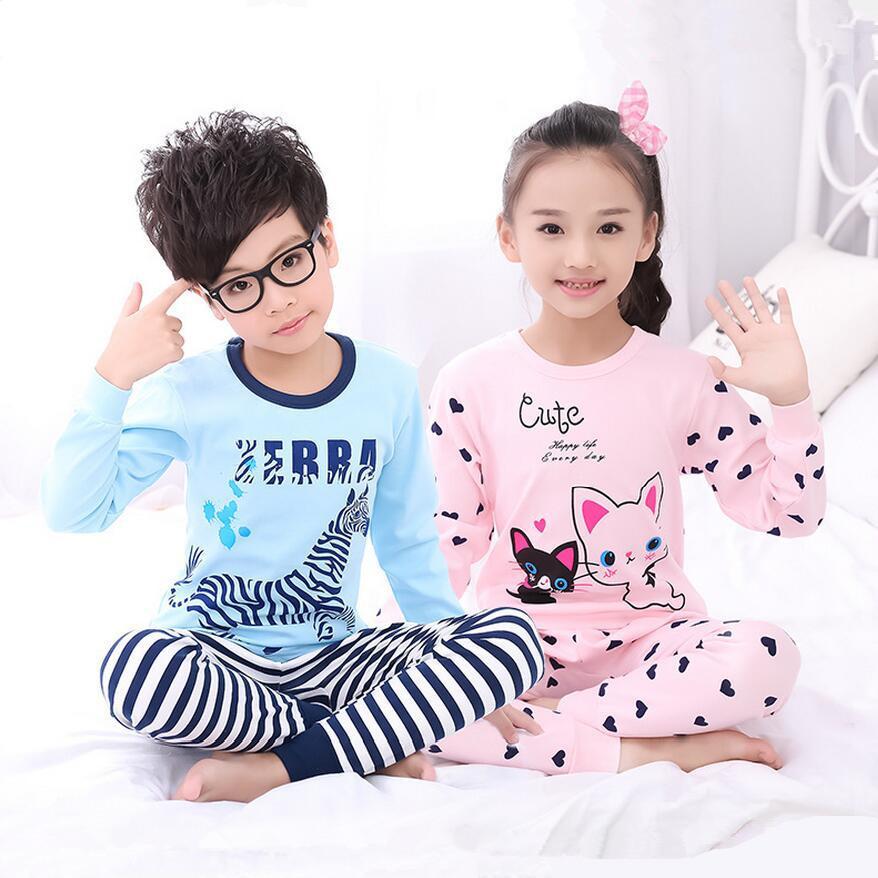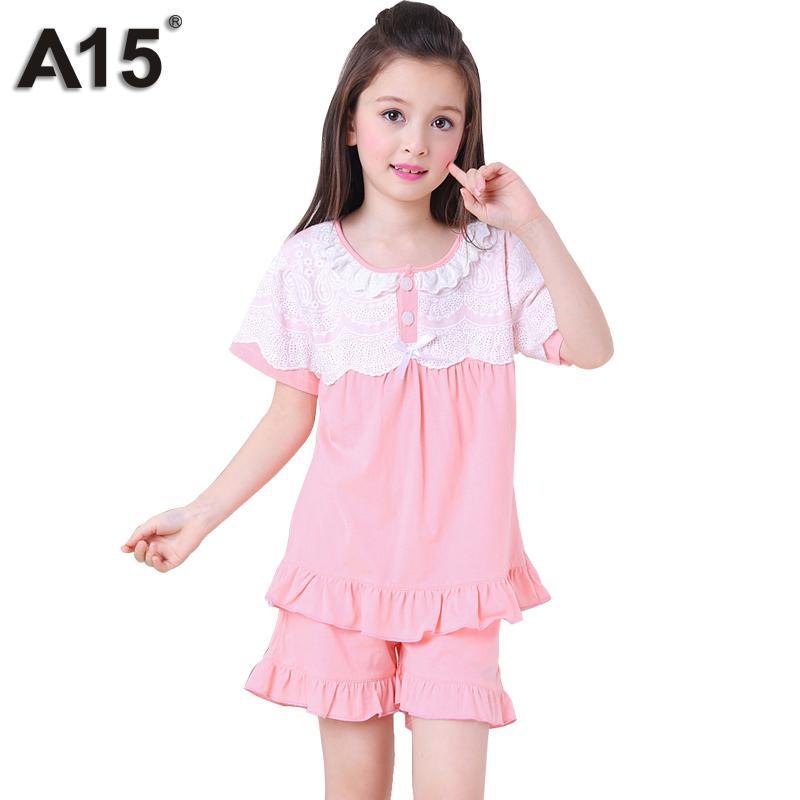The first image is the image on the left, the second image is the image on the right. Given the left and right images, does the statement "The right image contains three children." hold true? Answer yes or no. No. The first image is the image on the left, the second image is the image on the right. For the images shown, is this caption "One girl is wearing shorts." true? Answer yes or no. Yes. 